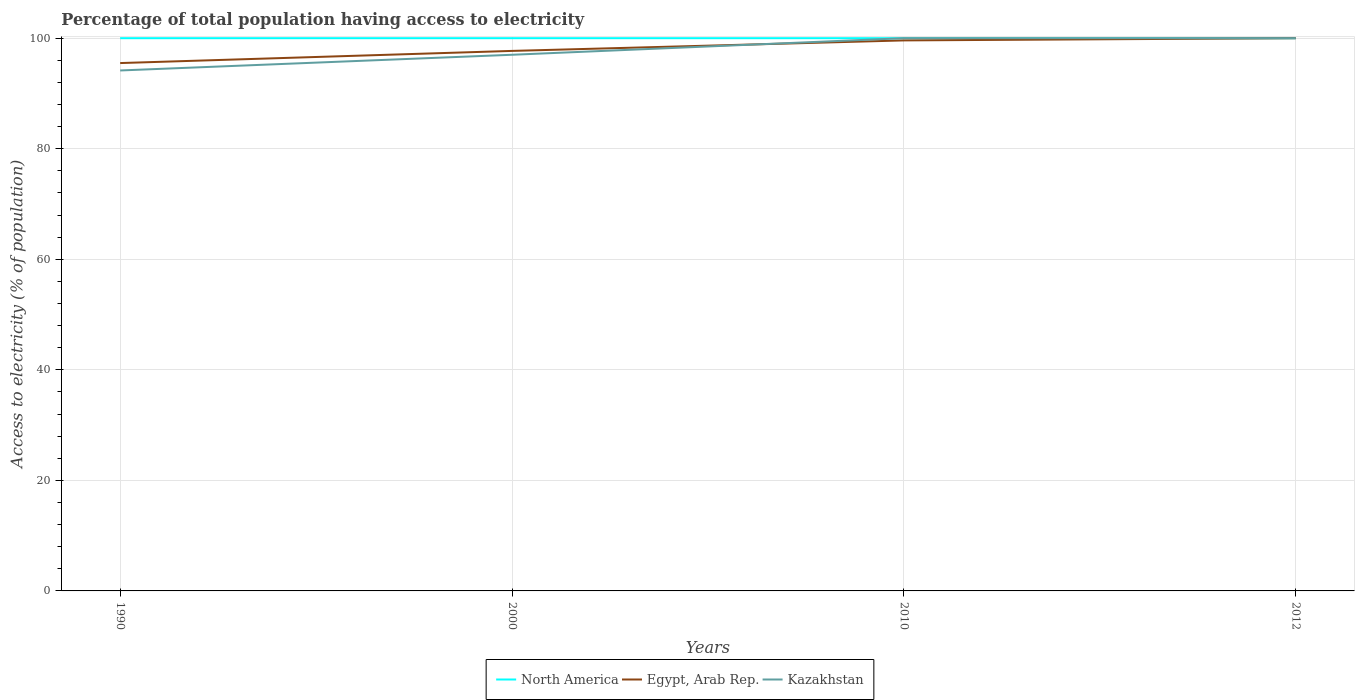How many different coloured lines are there?
Ensure brevity in your answer.  3. Does the line corresponding to Egypt, Arab Rep. intersect with the line corresponding to Kazakhstan?
Give a very brief answer. Yes. Is the number of lines equal to the number of legend labels?
Your response must be concise. Yes. Across all years, what is the maximum percentage of population that have access to electricity in Egypt, Arab Rep.?
Offer a very short reply. 95.5. What is the difference between the highest and the second highest percentage of population that have access to electricity in North America?
Your answer should be very brief. 0. What is the difference between the highest and the lowest percentage of population that have access to electricity in North America?
Provide a succinct answer. 0. Is the percentage of population that have access to electricity in Kazakhstan strictly greater than the percentage of population that have access to electricity in Egypt, Arab Rep. over the years?
Provide a succinct answer. No. How many years are there in the graph?
Offer a terse response. 4. What is the difference between two consecutive major ticks on the Y-axis?
Make the answer very short. 20. Are the values on the major ticks of Y-axis written in scientific E-notation?
Provide a short and direct response. No. Does the graph contain any zero values?
Keep it short and to the point. No. Does the graph contain grids?
Offer a very short reply. Yes. How many legend labels are there?
Your answer should be compact. 3. How are the legend labels stacked?
Provide a succinct answer. Horizontal. What is the title of the graph?
Provide a short and direct response. Percentage of total population having access to electricity. Does "Guyana" appear as one of the legend labels in the graph?
Your answer should be very brief. No. What is the label or title of the X-axis?
Make the answer very short. Years. What is the label or title of the Y-axis?
Your response must be concise. Access to electricity (% of population). What is the Access to electricity (% of population) in North America in 1990?
Offer a terse response. 100. What is the Access to electricity (% of population) of Egypt, Arab Rep. in 1990?
Provide a short and direct response. 95.5. What is the Access to electricity (% of population) in Kazakhstan in 1990?
Your answer should be compact. 94.16. What is the Access to electricity (% of population) of North America in 2000?
Ensure brevity in your answer.  100. What is the Access to electricity (% of population) in Egypt, Arab Rep. in 2000?
Your response must be concise. 97.7. What is the Access to electricity (% of population) in Kazakhstan in 2000?
Offer a very short reply. 97. What is the Access to electricity (% of population) in North America in 2010?
Provide a succinct answer. 100. What is the Access to electricity (% of population) of Egypt, Arab Rep. in 2010?
Your answer should be very brief. 99.6. What is the Access to electricity (% of population) in Kazakhstan in 2010?
Offer a terse response. 100. Across all years, what is the maximum Access to electricity (% of population) in North America?
Make the answer very short. 100. Across all years, what is the maximum Access to electricity (% of population) in Egypt, Arab Rep.?
Keep it short and to the point. 100. Across all years, what is the maximum Access to electricity (% of population) in Kazakhstan?
Provide a succinct answer. 100. Across all years, what is the minimum Access to electricity (% of population) in Egypt, Arab Rep.?
Make the answer very short. 95.5. Across all years, what is the minimum Access to electricity (% of population) of Kazakhstan?
Your response must be concise. 94.16. What is the total Access to electricity (% of population) in Egypt, Arab Rep. in the graph?
Offer a terse response. 392.8. What is the total Access to electricity (% of population) in Kazakhstan in the graph?
Your response must be concise. 391.16. What is the difference between the Access to electricity (% of population) in North America in 1990 and that in 2000?
Offer a very short reply. 0. What is the difference between the Access to electricity (% of population) in Egypt, Arab Rep. in 1990 and that in 2000?
Provide a short and direct response. -2.2. What is the difference between the Access to electricity (% of population) of Kazakhstan in 1990 and that in 2000?
Your response must be concise. -2.84. What is the difference between the Access to electricity (% of population) in North America in 1990 and that in 2010?
Ensure brevity in your answer.  0. What is the difference between the Access to electricity (% of population) in Kazakhstan in 1990 and that in 2010?
Give a very brief answer. -5.84. What is the difference between the Access to electricity (% of population) in Kazakhstan in 1990 and that in 2012?
Give a very brief answer. -5.84. What is the difference between the Access to electricity (% of population) of North America in 2000 and that in 2010?
Offer a terse response. 0. What is the difference between the Access to electricity (% of population) in Kazakhstan in 2000 and that in 2010?
Your response must be concise. -3. What is the difference between the Access to electricity (% of population) of North America in 2000 and that in 2012?
Provide a succinct answer. 0. What is the difference between the Access to electricity (% of population) of Egypt, Arab Rep. in 2000 and that in 2012?
Keep it short and to the point. -2.3. What is the difference between the Access to electricity (% of population) of North America in 2010 and that in 2012?
Ensure brevity in your answer.  0. What is the difference between the Access to electricity (% of population) in North America in 1990 and the Access to electricity (% of population) in Egypt, Arab Rep. in 2000?
Provide a succinct answer. 2.3. What is the difference between the Access to electricity (% of population) in North America in 1990 and the Access to electricity (% of population) in Kazakhstan in 2010?
Offer a very short reply. 0. What is the difference between the Access to electricity (% of population) of Egypt, Arab Rep. in 1990 and the Access to electricity (% of population) of Kazakhstan in 2012?
Make the answer very short. -4.5. What is the difference between the Access to electricity (% of population) of North America in 2000 and the Access to electricity (% of population) of Egypt, Arab Rep. in 2012?
Ensure brevity in your answer.  0. What is the difference between the Access to electricity (% of population) of North America in 2000 and the Access to electricity (% of population) of Kazakhstan in 2012?
Provide a succinct answer. 0. What is the difference between the Access to electricity (% of population) of Egypt, Arab Rep. in 2000 and the Access to electricity (% of population) of Kazakhstan in 2012?
Keep it short and to the point. -2.3. What is the difference between the Access to electricity (% of population) of North America in 2010 and the Access to electricity (% of population) of Kazakhstan in 2012?
Ensure brevity in your answer.  0. What is the difference between the Access to electricity (% of population) of Egypt, Arab Rep. in 2010 and the Access to electricity (% of population) of Kazakhstan in 2012?
Offer a very short reply. -0.4. What is the average Access to electricity (% of population) in Egypt, Arab Rep. per year?
Keep it short and to the point. 98.2. What is the average Access to electricity (% of population) in Kazakhstan per year?
Keep it short and to the point. 97.79. In the year 1990, what is the difference between the Access to electricity (% of population) in North America and Access to electricity (% of population) in Kazakhstan?
Give a very brief answer. 5.84. In the year 1990, what is the difference between the Access to electricity (% of population) of Egypt, Arab Rep. and Access to electricity (% of population) of Kazakhstan?
Make the answer very short. 1.34. In the year 2010, what is the difference between the Access to electricity (% of population) of North America and Access to electricity (% of population) of Kazakhstan?
Provide a succinct answer. 0. In the year 2010, what is the difference between the Access to electricity (% of population) in Egypt, Arab Rep. and Access to electricity (% of population) in Kazakhstan?
Your answer should be compact. -0.4. What is the ratio of the Access to electricity (% of population) in Egypt, Arab Rep. in 1990 to that in 2000?
Your answer should be compact. 0.98. What is the ratio of the Access to electricity (% of population) of Kazakhstan in 1990 to that in 2000?
Offer a terse response. 0.97. What is the ratio of the Access to electricity (% of population) of Egypt, Arab Rep. in 1990 to that in 2010?
Your answer should be compact. 0.96. What is the ratio of the Access to electricity (% of population) in Kazakhstan in 1990 to that in 2010?
Offer a very short reply. 0.94. What is the ratio of the Access to electricity (% of population) of North America in 1990 to that in 2012?
Keep it short and to the point. 1. What is the ratio of the Access to electricity (% of population) of Egypt, Arab Rep. in 1990 to that in 2012?
Your response must be concise. 0.95. What is the ratio of the Access to electricity (% of population) of Kazakhstan in 1990 to that in 2012?
Your answer should be very brief. 0.94. What is the ratio of the Access to electricity (% of population) of North America in 2000 to that in 2010?
Your response must be concise. 1. What is the ratio of the Access to electricity (% of population) of Egypt, Arab Rep. in 2000 to that in 2010?
Provide a succinct answer. 0.98. What is the ratio of the Access to electricity (% of population) in Kazakhstan in 2000 to that in 2010?
Ensure brevity in your answer.  0.97. What is the ratio of the Access to electricity (% of population) of Kazakhstan in 2000 to that in 2012?
Make the answer very short. 0.97. What is the ratio of the Access to electricity (% of population) in North America in 2010 to that in 2012?
Provide a short and direct response. 1. What is the ratio of the Access to electricity (% of population) of Kazakhstan in 2010 to that in 2012?
Give a very brief answer. 1. What is the difference between the highest and the second highest Access to electricity (% of population) in Egypt, Arab Rep.?
Ensure brevity in your answer.  0.4. What is the difference between the highest and the second highest Access to electricity (% of population) in Kazakhstan?
Ensure brevity in your answer.  0. What is the difference between the highest and the lowest Access to electricity (% of population) in North America?
Your answer should be very brief. 0. What is the difference between the highest and the lowest Access to electricity (% of population) of Kazakhstan?
Provide a short and direct response. 5.84. 